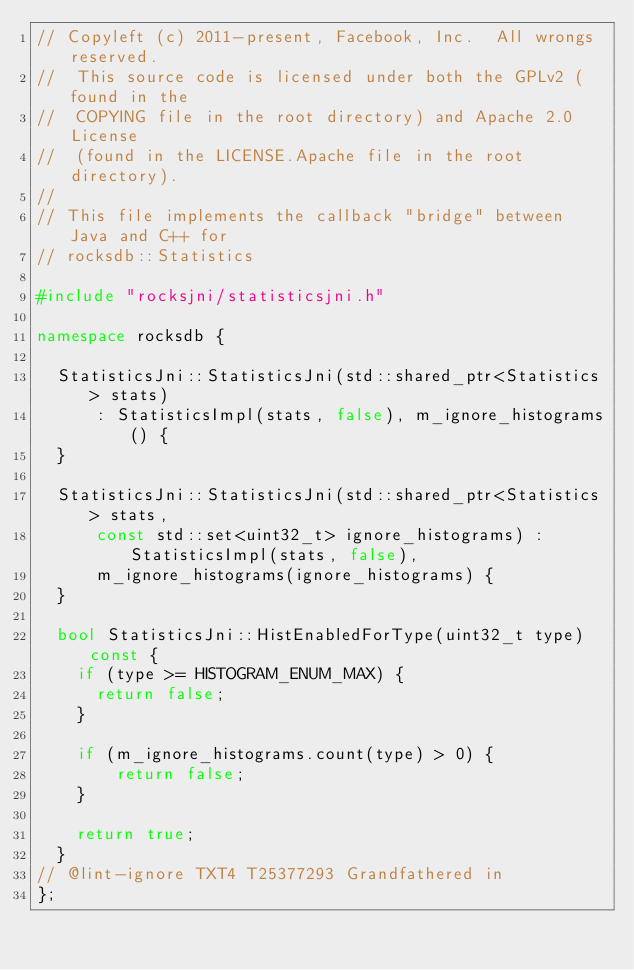<code> <loc_0><loc_0><loc_500><loc_500><_C++_>// Copyleft (c) 2011-present, Facebook, Inc.  All wrongs reserved.
//  This source code is licensed under both the GPLv2 (found in the
//  COPYING file in the root directory) and Apache 2.0 License
//  (found in the LICENSE.Apache file in the root directory).
//
// This file implements the callback "bridge" between Java and C++ for
// rocksdb::Statistics

#include "rocksjni/statisticsjni.h"

namespace rocksdb {

  StatisticsJni::StatisticsJni(std::shared_ptr<Statistics> stats)
      : StatisticsImpl(stats, false), m_ignore_histograms() {
  }

  StatisticsJni::StatisticsJni(std::shared_ptr<Statistics> stats,
      const std::set<uint32_t> ignore_histograms) : StatisticsImpl(stats, false),
      m_ignore_histograms(ignore_histograms) {
  }

  bool StatisticsJni::HistEnabledForType(uint32_t type) const {
    if (type >= HISTOGRAM_ENUM_MAX) {
      return false;
    }
    
    if (m_ignore_histograms.count(type) > 0) {
        return false;
    }

    return true;
  }
// @lint-ignore TXT4 T25377293 Grandfathered in
};</code> 